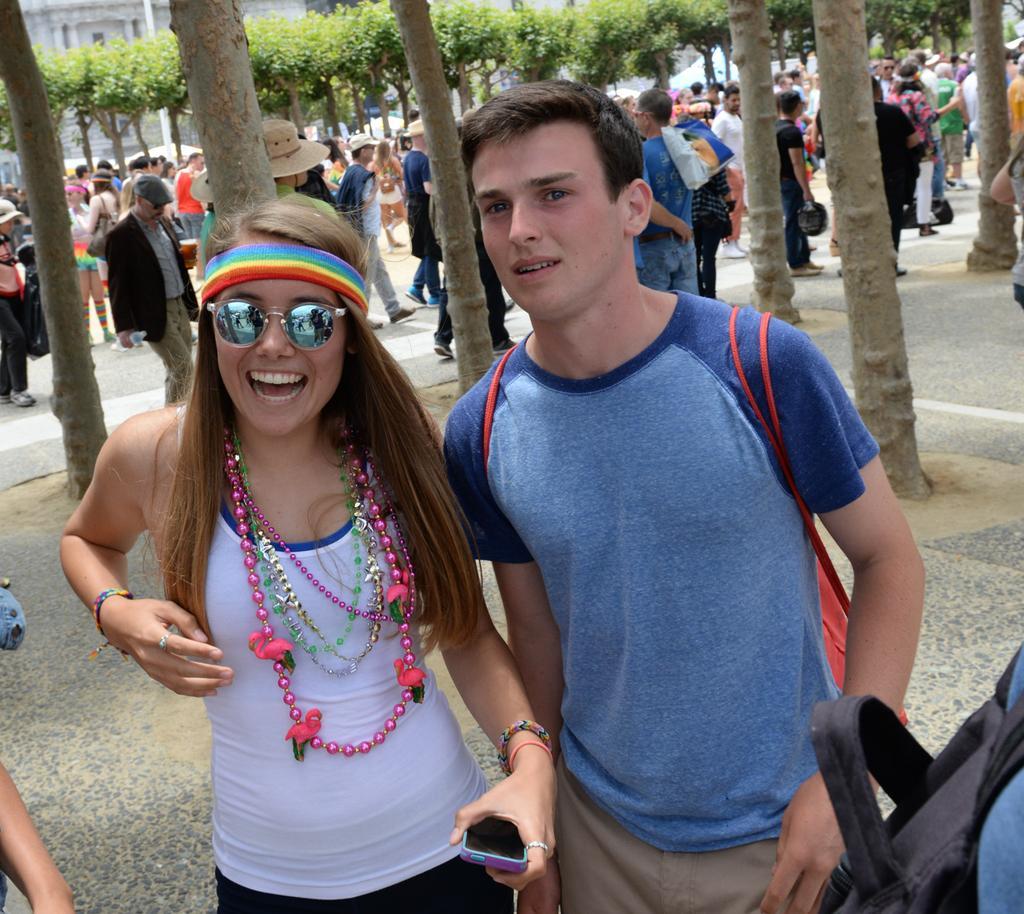Please provide a concise description of this image. In this image i can see a woman and man standing on the ground And she is smiling and i can see a person hand visible on the left side and at the top I can see trees and stem of the tree and a person visible on the road. 